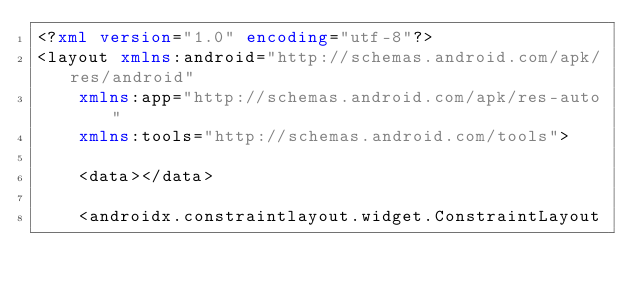<code> <loc_0><loc_0><loc_500><loc_500><_XML_><?xml version="1.0" encoding="utf-8"?>
<layout xmlns:android="http://schemas.android.com/apk/res/android"
    xmlns:app="http://schemas.android.com/apk/res-auto"
    xmlns:tools="http://schemas.android.com/tools">

    <data></data>

    <androidx.constraintlayout.widget.ConstraintLayout</code> 